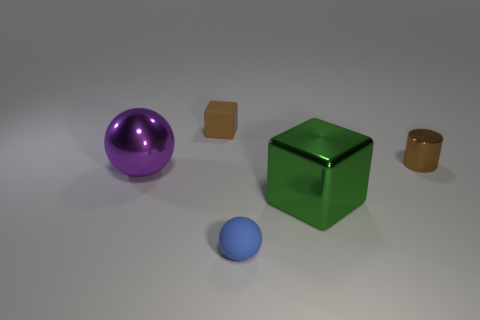Add 1 small blue rubber balls. How many objects exist? 6 Subtract all balls. How many objects are left? 3 Subtract 0 green cylinders. How many objects are left? 5 Subtract all tiny gray metallic cylinders. Subtract all small matte spheres. How many objects are left? 4 Add 4 large green metallic objects. How many large green metallic objects are left? 5 Add 3 large green metal things. How many large green metal things exist? 4 